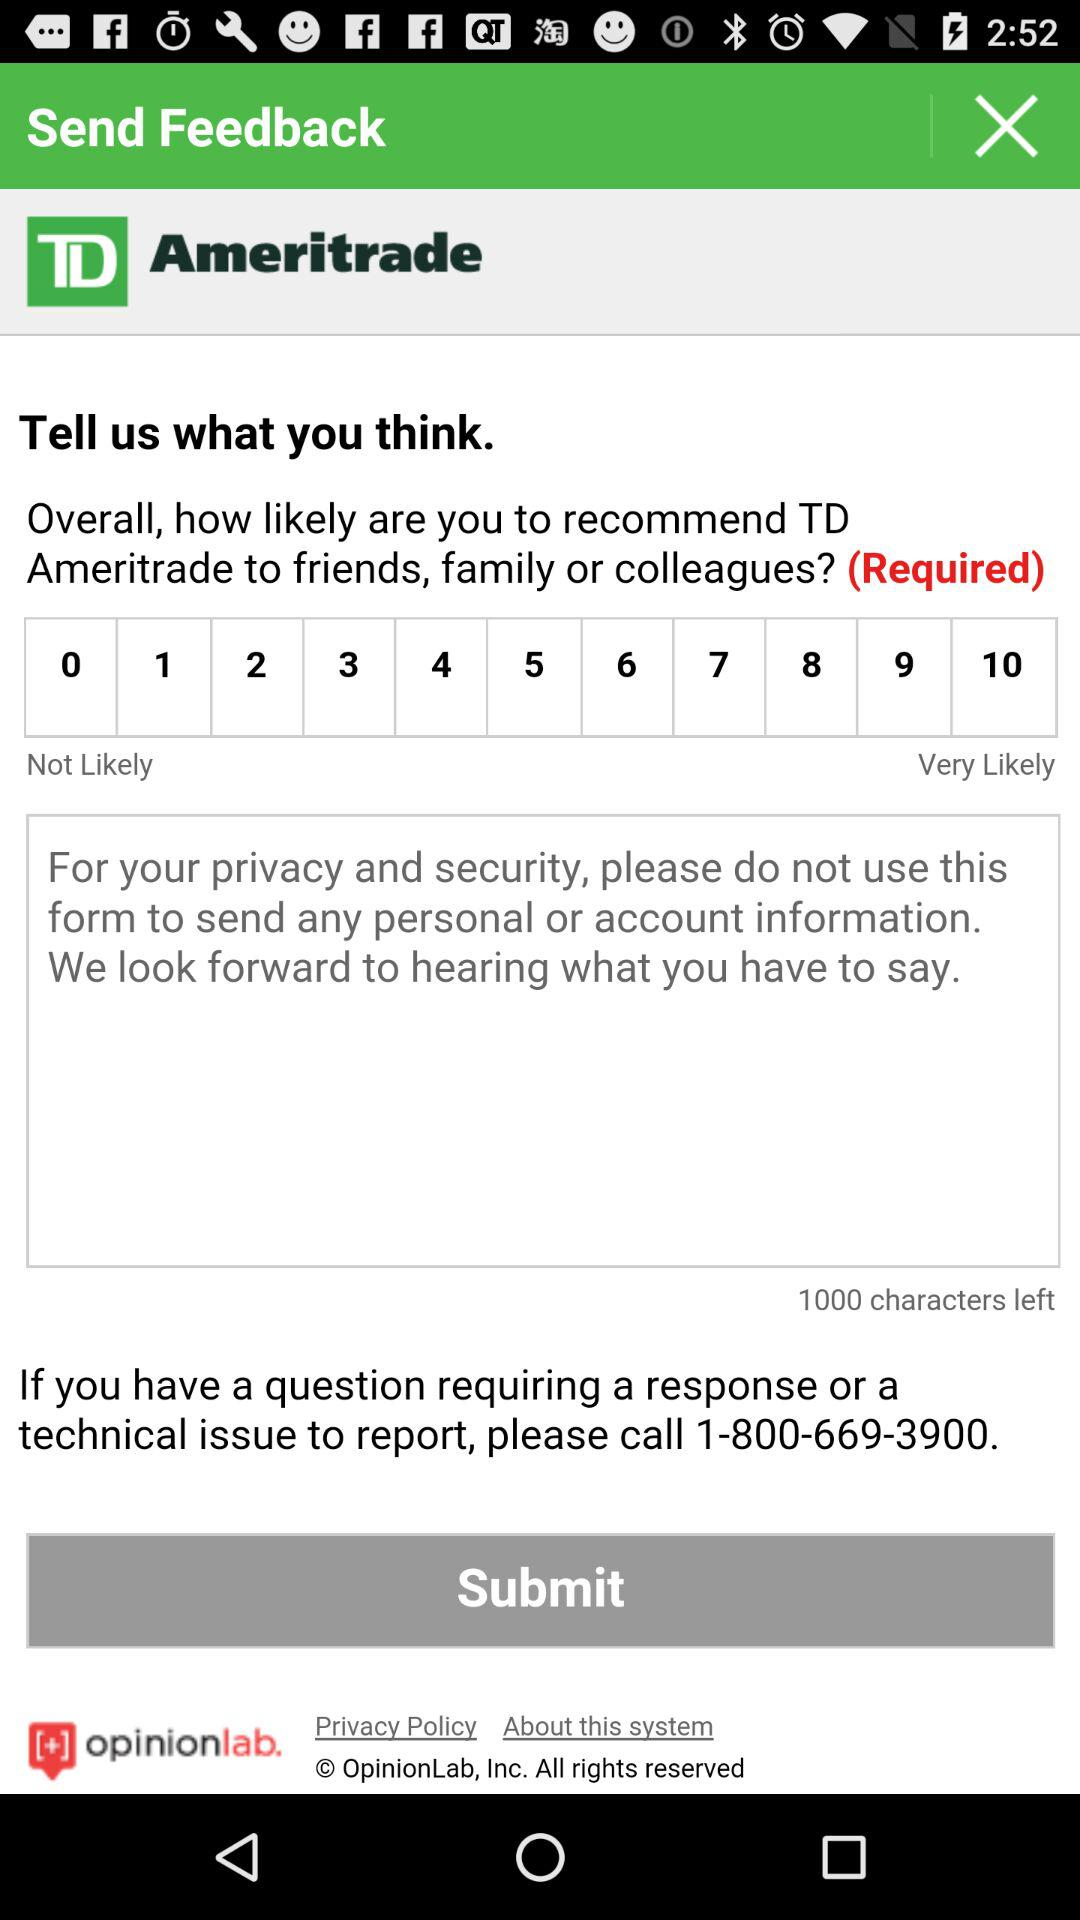Which number is selected for TD recommendation?
When the provided information is insufficient, respond with <no answer>. <no answer> 